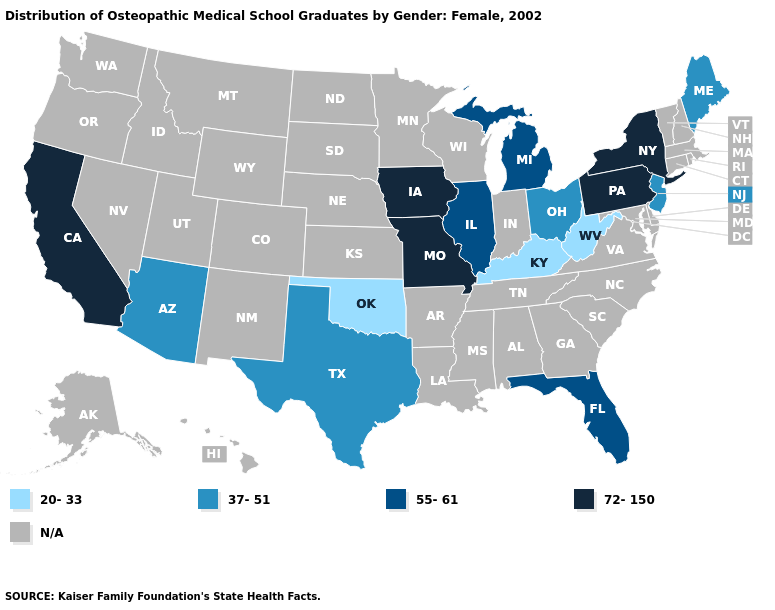What is the highest value in the MidWest ?
Give a very brief answer. 72-150. Is the legend a continuous bar?
Keep it brief. No. Among the states that border Massachusetts , which have the lowest value?
Be succinct. New York. Does California have the lowest value in the USA?
Short answer required. No. Does Kentucky have the lowest value in the USA?
Concise answer only. Yes. Name the states that have a value in the range 72-150?
Quick response, please. California, Iowa, Missouri, New York, Pennsylvania. What is the highest value in the USA?
Short answer required. 72-150. Name the states that have a value in the range 72-150?
Answer briefly. California, Iowa, Missouri, New York, Pennsylvania. Name the states that have a value in the range 55-61?
Quick response, please. Florida, Illinois, Michigan. What is the value of Virginia?
Keep it brief. N/A. Which states have the lowest value in the USA?
Keep it brief. Kentucky, Oklahoma, West Virginia. What is the lowest value in states that border Oregon?
Keep it brief. 72-150. Which states hav the highest value in the MidWest?
Keep it brief. Iowa, Missouri. Among the states that border West Virginia , does Pennsylvania have the lowest value?
Answer briefly. No. What is the value of Alabama?
Be succinct. N/A. 